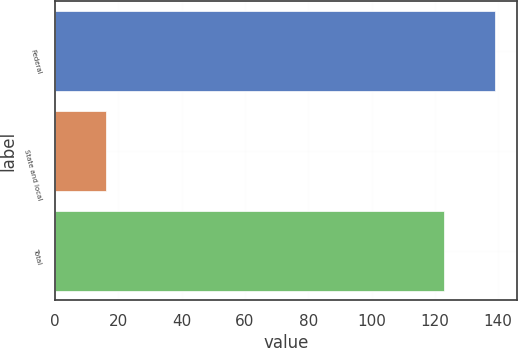Convert chart. <chart><loc_0><loc_0><loc_500><loc_500><bar_chart><fcel>Federal<fcel>State and local<fcel>Total<nl><fcel>139<fcel>16<fcel>123<nl></chart> 